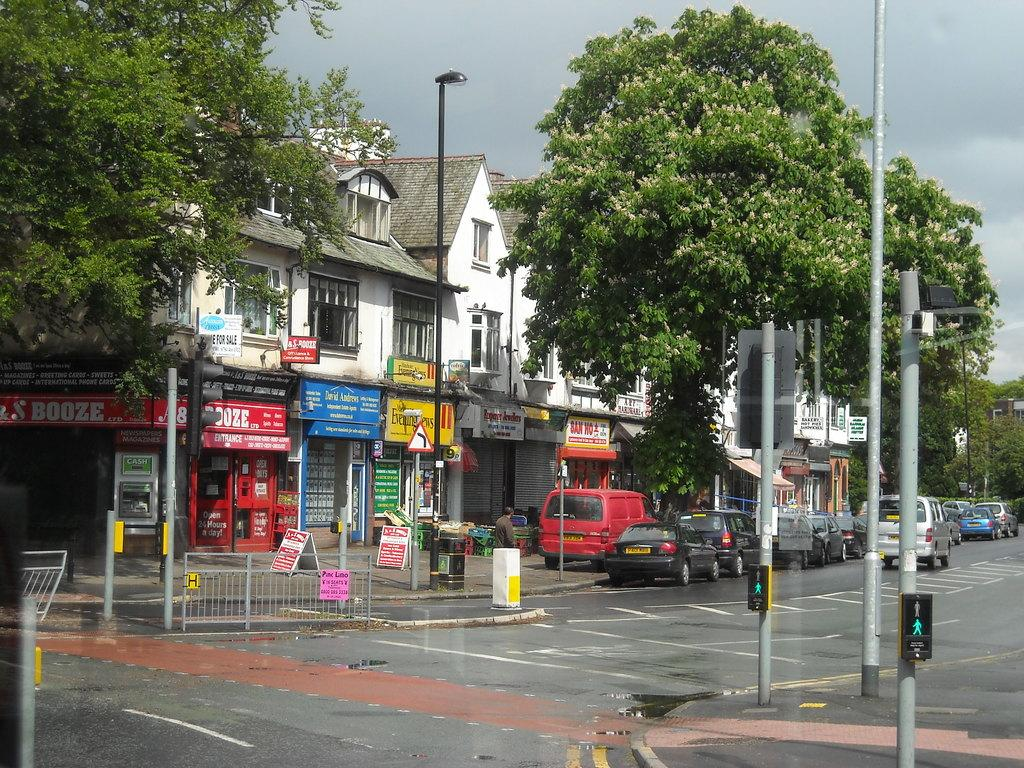<image>
Provide a brief description of the given image. A red sign on a corner shop has a word that ends with oze on it. 